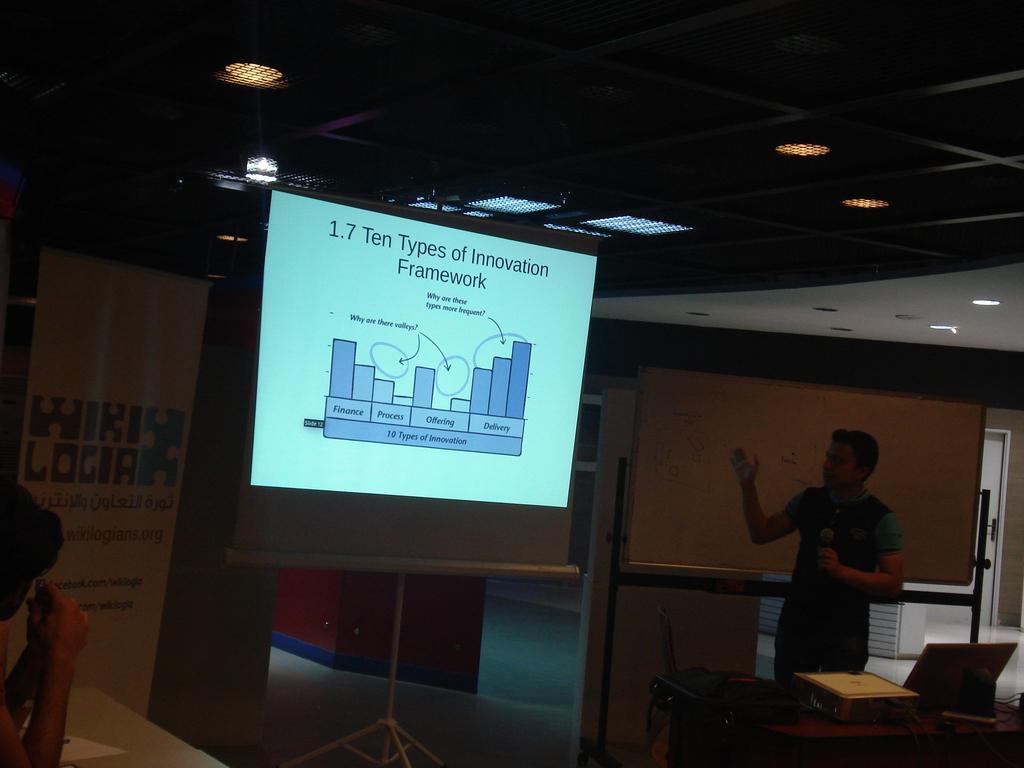Can you describe this image briefly? In this image I can see a man is standing and holding a mic. Here I can see a projector's screen. I can also see one more person over here. 